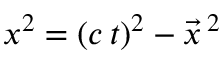Convert formula to latex. <formula><loc_0><loc_0><loc_500><loc_500>x ^ { 2 } = ( c \, t ) ^ { 2 } - \vec { x } \, ^ { 2 }</formula> 